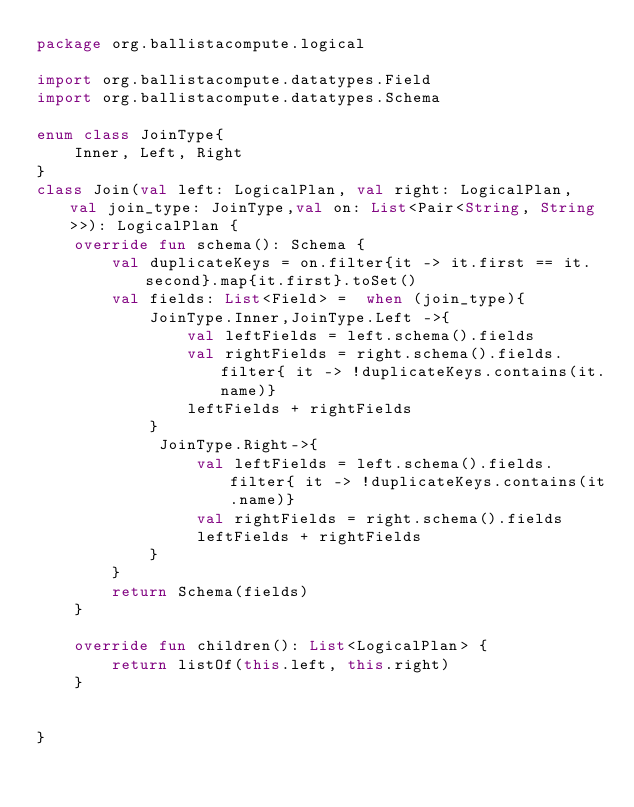<code> <loc_0><loc_0><loc_500><loc_500><_Kotlin_>package org.ballistacompute.logical

import org.ballistacompute.datatypes.Field
import org.ballistacompute.datatypes.Schema

enum class JoinType{
    Inner, Left, Right
}
class Join(val left: LogicalPlan, val right: LogicalPlan, val join_type: JoinType,val on: List<Pair<String, String>>): LogicalPlan {
    override fun schema(): Schema {
        val duplicateKeys = on.filter{it -> it.first == it.second}.map{it.first}.toSet()
        val fields: List<Field> =  when (join_type){
            JoinType.Inner,JoinType.Left ->{
                val leftFields = left.schema().fields
                val rightFields = right.schema().fields.filter{ it -> !duplicateKeys.contains(it.name)}
                leftFields + rightFields
            }
             JoinType.Right->{
                 val leftFields = left.schema().fields.filter{ it -> !duplicateKeys.contains(it.name)}
                 val rightFields = right.schema().fields
                 leftFields + rightFields
            }
        }
        return Schema(fields)
    }

    override fun children(): List<LogicalPlan> {
        return listOf(this.left, this.right)
    }


}</code> 